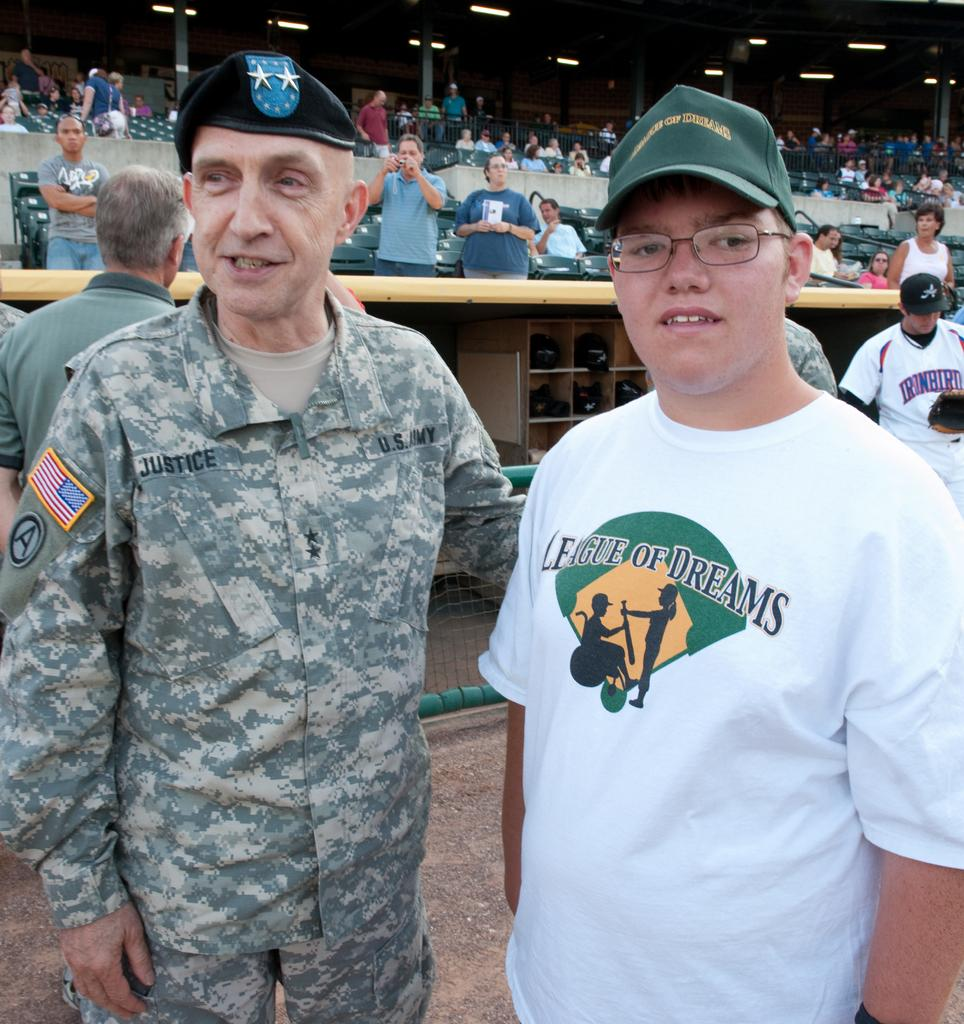<image>
Relay a brief, clear account of the picture shown. A man who is standing next to a military officer is wearing a League of Dreams T-shirt 